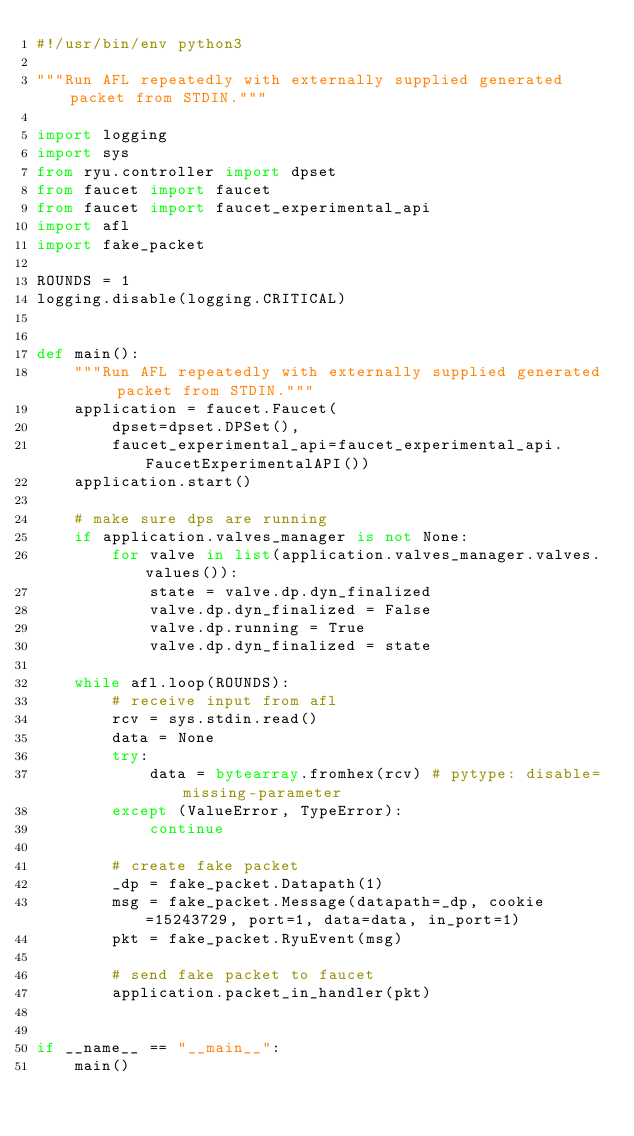<code> <loc_0><loc_0><loc_500><loc_500><_Python_>#!/usr/bin/env python3

"""Run AFL repeatedly with externally supplied generated packet from STDIN."""

import logging
import sys
from ryu.controller import dpset
from faucet import faucet
from faucet import faucet_experimental_api
import afl
import fake_packet

ROUNDS = 1
logging.disable(logging.CRITICAL)


def main():
    """Run AFL repeatedly with externally supplied generated packet from STDIN."""
    application = faucet.Faucet(
        dpset=dpset.DPSet(),
        faucet_experimental_api=faucet_experimental_api.FaucetExperimentalAPI())
    application.start()

    # make sure dps are running
    if application.valves_manager is not None:
        for valve in list(application.valves_manager.valves.values()):
            state = valve.dp.dyn_finalized
            valve.dp.dyn_finalized = False
            valve.dp.running = True
            valve.dp.dyn_finalized = state

    while afl.loop(ROUNDS):
        # receive input from afl
        rcv = sys.stdin.read()
        data = None
        try:
            data = bytearray.fromhex(rcv) # pytype: disable=missing-parameter
        except (ValueError, TypeError):
            continue

        # create fake packet
        _dp = fake_packet.Datapath(1)
        msg = fake_packet.Message(datapath=_dp, cookie=15243729, port=1, data=data, in_port=1)
        pkt = fake_packet.RyuEvent(msg)

        # send fake packet to faucet
        application.packet_in_handler(pkt)


if __name__ == "__main__":
    main()
</code> 